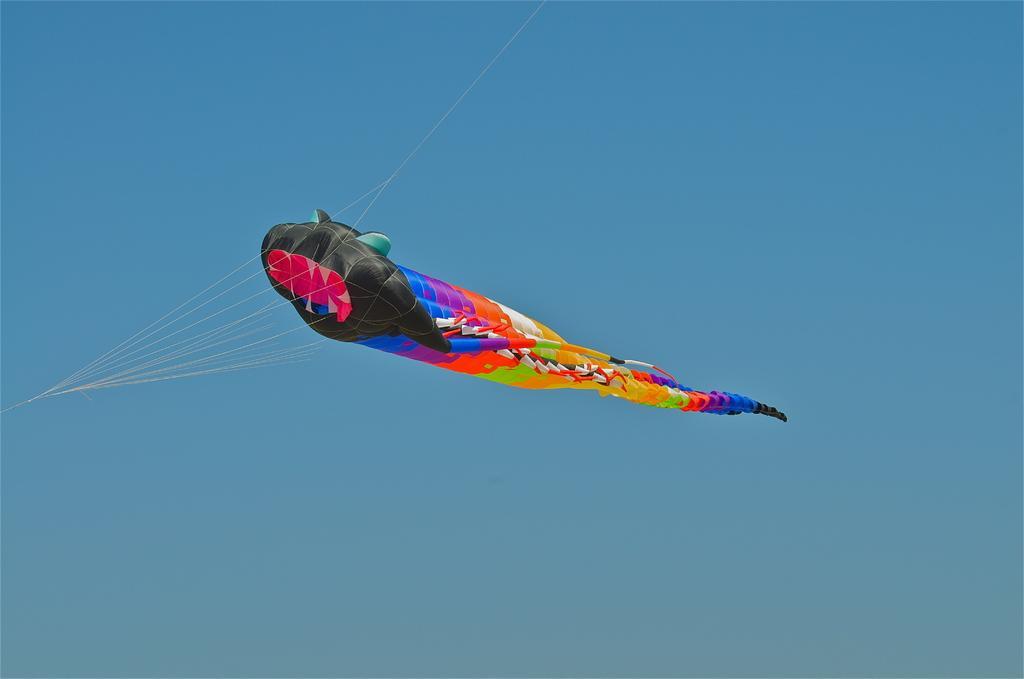Can you describe this image briefly? In this image I can see a colorful kite is flying in the air and few ropes attached to it. In the background I can see the sky. 